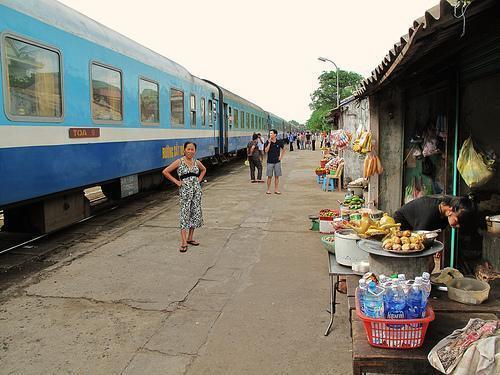How many people have on a dress?
Give a very brief answer. 1. 